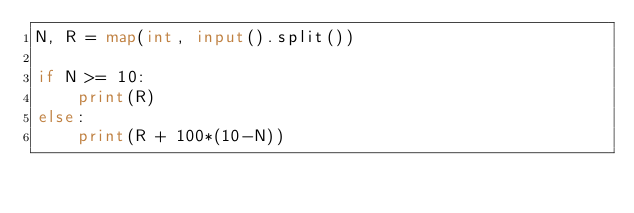<code> <loc_0><loc_0><loc_500><loc_500><_Python_>N, R = map(int, input().split())

if N >= 10:
    print(R)
else:
    print(R + 100*(10-N))
</code> 